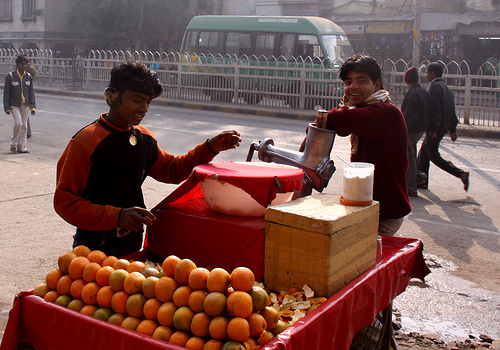<image>
Is there a fruits behind the man? Yes. From this viewpoint, the fruits is positioned behind the man, with the man partially or fully occluding the fruits. 